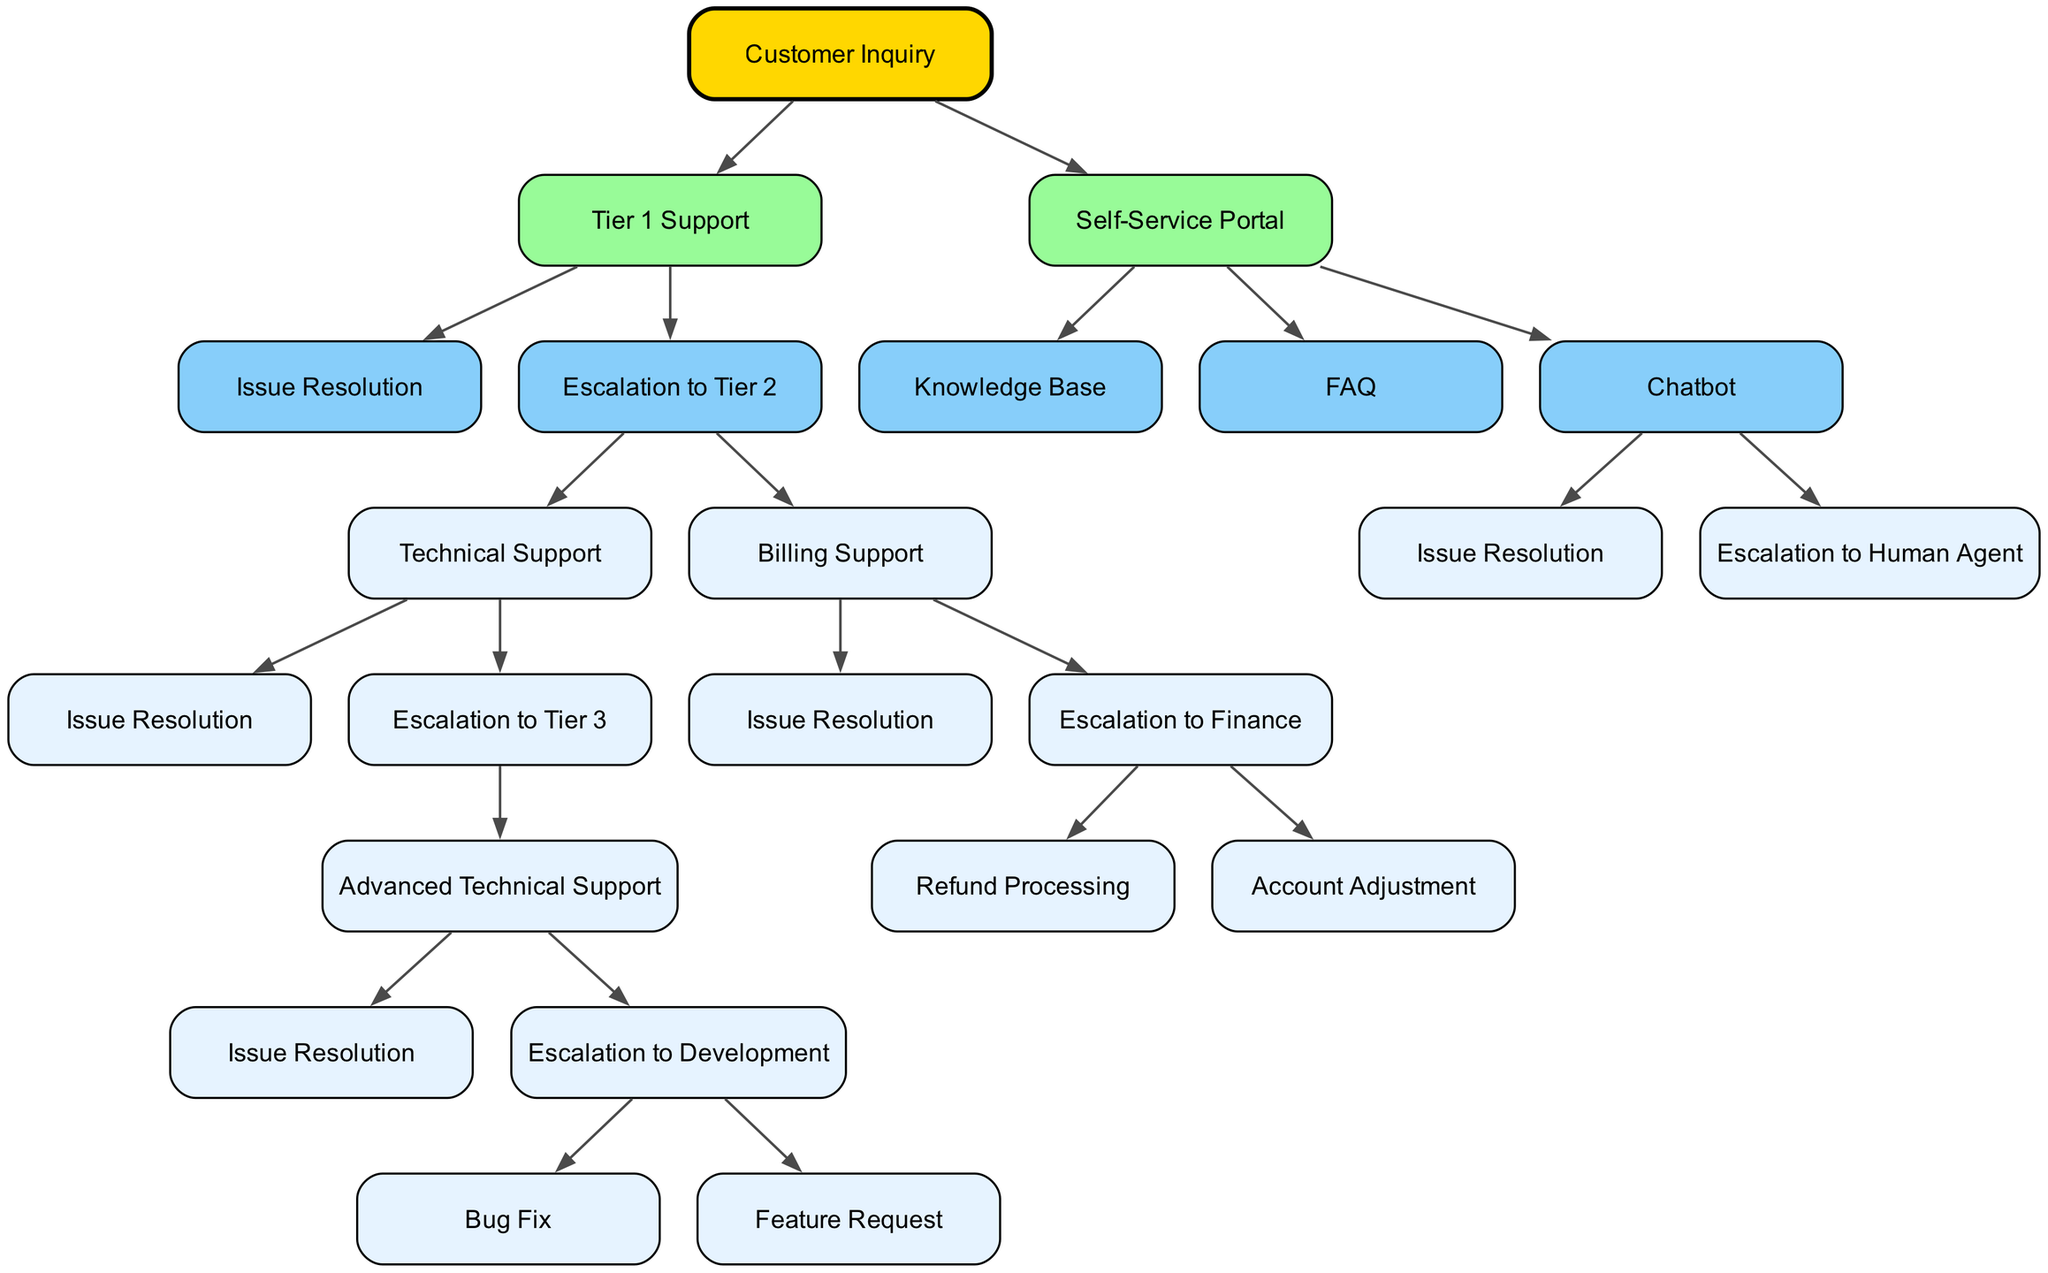What does Tier 1 Support escalate to? In the diagram, Tier 1 Support has two distinct paths for escalation: Technical Support and Billing Support. This indicates that depending on the nature of the customer inquiry, the support can either focus on technical issues or billing issues, leading to different escalation flows.
Answer: Technical Support and Billing Support How many resolution paths are there in Tier 2? In Tier 2, there are two main paths for resolution: one path connects to Technical Support and the other connects to Billing Support. Each of these can further escalate to Tier 3 or an external department, but in terms of direct resolution paths, there are two.
Answer: Two What happens after escalation to Tier 2 from Tier 1? After escalating to Tier 2 from Tier 1, the inquiry branches into either Technical Support or Billing Support. Each of these branches may lead to distinct resolution options or further escalation, indicating multiple potential outcomes based on the nature of the issue.
Answer: Becomes either Technical Support or Billing Support Which node signifies the final escalation step in the technical support pathway? The final escalation step in the technical support pathway is to Development. Tracking back from Tier 1 Support through Technical Support and Advanced Technical Support leads directly to this final escalation point, focusing on bug fixes or feature requests.
Answer: Development How does the escalation from Chatbot occur? The escalation from the Chatbot occurs after an issue resolution attempt. If the Chatbot cannot resolve the inquiry adequately, it escalates the case to a Human Agent. This reflects a structured approach to handle customer inquiries that could not be processed by automated tools.
Answer: Escalation to Human Agent What is the top-level node of the diagram? The top-level node of the diagram represents Customer Inquiry. This encompasses all pathways and support tiers that respond to customer needs, functioning as the initial point of departure for the resolution process.
Answer: Customer Inquiry How many nodes exist under the Self-Service Portal? The Self-Service Portal contains three distinct nodes: Knowledge Base, FAQ, and Chatbot. Each of these components serves as self-service options for customers seeking assistance without direct agent intervention, thus encompassing the self-service aspect of customer support.
Answer: Three What kind of support is escalated to Finance? The support escalated to Finance pertains to billing issues. This specific escalation indicates a structured response when customer inquiries involve financial transactions or account-related concerns, demonstrating a specialized route for billing escalations.
Answer: Billing Support What are the types of resolutions available in Advanced Technical Support? Advanced Technical Support offers two specific resolution types: Bug Fix and Feature Request. These outcomes are distinct paths that target specific types of technical issues that may require deeper expertise and perhaps longer resolution times.
Answer: Bug Fix and Feature Request 